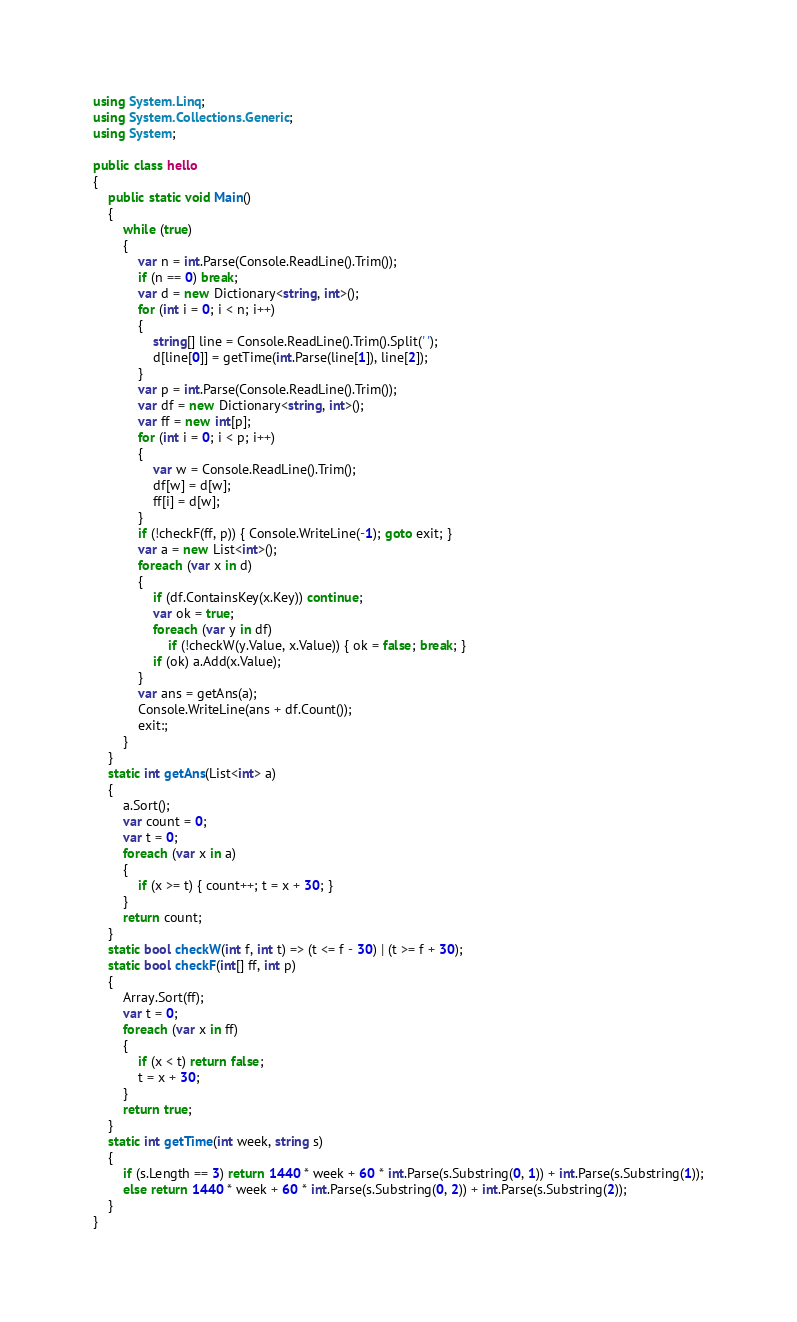<code> <loc_0><loc_0><loc_500><loc_500><_C#_>using System.Linq;
using System.Collections.Generic;
using System;

public class hello
{
    public static void Main()
    {
        while (true)
        {
            var n = int.Parse(Console.ReadLine().Trim());
            if (n == 0) break;
            var d = new Dictionary<string, int>();
            for (int i = 0; i < n; i++)
            {
                string[] line = Console.ReadLine().Trim().Split(' ');
                d[line[0]] = getTime(int.Parse(line[1]), line[2]);
            }
            var p = int.Parse(Console.ReadLine().Trim());
            var df = new Dictionary<string, int>();
            var ff = new int[p];
            for (int i = 0; i < p; i++)
            {
                var w = Console.ReadLine().Trim();
                df[w] = d[w];
                ff[i] = d[w];
            }
            if (!checkF(ff, p)) { Console.WriteLine(-1); goto exit; }
            var a = new List<int>();
            foreach (var x in d)
            {
                if (df.ContainsKey(x.Key)) continue;
                var ok = true;
                foreach (var y in df)
                    if (!checkW(y.Value, x.Value)) { ok = false; break; }
                if (ok) a.Add(x.Value);
            }
            var ans = getAns(a);
            Console.WriteLine(ans + df.Count());
            exit:;
        }
    }
    static int getAns(List<int> a)
    {
        a.Sort();
        var count = 0;
        var t = 0;
        foreach (var x in a)
        {
            if (x >= t) { count++; t = x + 30; }
        }
        return count;
    }
    static bool checkW(int f, int t) => (t <= f - 30) | (t >= f + 30);
    static bool checkF(int[] ff, int p)
    {
        Array.Sort(ff);
        var t = 0;
        foreach (var x in ff)
        {
            if (x < t) return false;
            t = x + 30;
        }
        return true;
    }
    static int getTime(int week, string s)
    {
        if (s.Length == 3) return 1440 * week + 60 * int.Parse(s.Substring(0, 1)) + int.Parse(s.Substring(1));
        else return 1440 * week + 60 * int.Parse(s.Substring(0, 2)) + int.Parse(s.Substring(2));
    }
}

</code> 